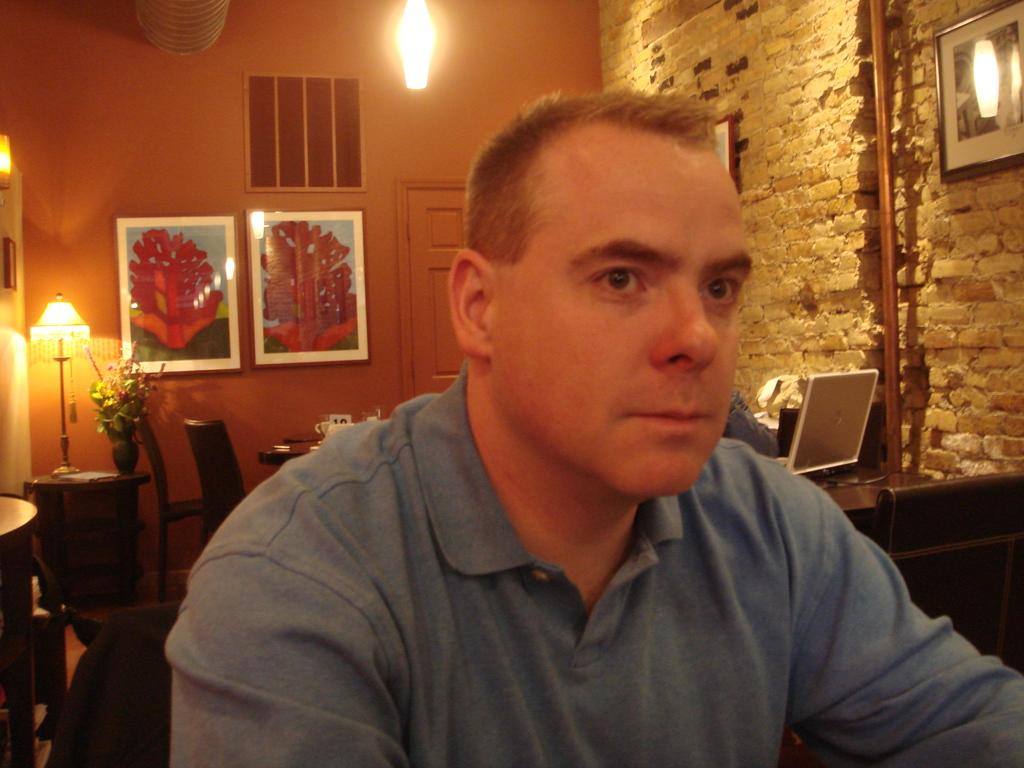What is the man in the image doing? The man is sitting in the image. What can be seen in the background of the image? There is a wall with frames, a door, a light, a chair, a table, a flower vase, a lamp, and a laptop in the background. Can you describe the objects on the wall in the background? The wall in the background has frames on it. What type of furniture is present in the background? There is a chair and a table in the background. How many horses are visible in the image? There are no horses present in the image. What type of guitar can be seen in the image? There is no guitar present in the image. 